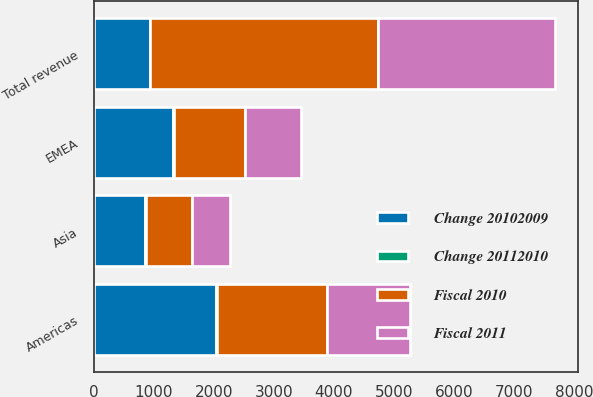Convert chart. <chart><loc_0><loc_0><loc_500><loc_500><stacked_bar_chart><ecel><fcel>Americas<fcel>EMEA<fcel>Asia<fcel>Total revenue<nl><fcel>Change 20102009<fcel>2044.6<fcel>1317.4<fcel>854.3<fcel>928.9<nl><fcel>Fiscal 2010<fcel>1835.3<fcel>1191.9<fcel>772.8<fcel>3800<nl><fcel>Fiscal 2011<fcel>1382.6<fcel>928.9<fcel>634.4<fcel>2945.9<nl><fcel>Change 20112010<fcel>11<fcel>11<fcel>11<fcel>11<nl></chart> 